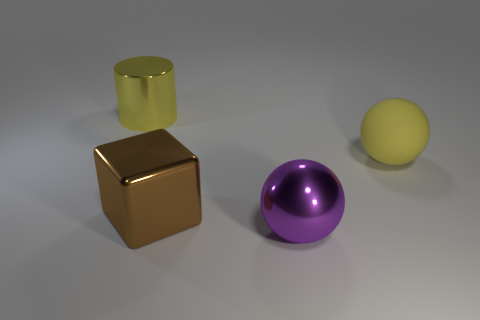Is the color of the rubber object the same as the large shiny cylinder?
Ensure brevity in your answer.  Yes. There is a rubber object; does it have the same color as the big shiny cylinder on the left side of the large shiny ball?
Offer a terse response. Yes. Is there any other thing that has the same color as the large cube?
Your answer should be compact. No. There is a ball that is the same color as the large cylinder; what size is it?
Your answer should be very brief. Large. What is the big yellow cylinder made of?
Your answer should be compact. Metal. Is the number of large yellow balls that are right of the big metal sphere the same as the number of large rubber things?
Give a very brief answer. Yes. Is the yellow thing that is to the left of the purple thing made of the same material as the yellow object that is in front of the yellow shiny object?
Keep it short and to the point. No. Is there anything else that has the same material as the big brown block?
Ensure brevity in your answer.  Yes. There is a large metal thing behind the rubber sphere; is it the same shape as the big yellow object on the right side of the cube?
Your answer should be compact. No. Are there fewer big blocks right of the big rubber thing than big yellow balls?
Provide a succinct answer. Yes. 